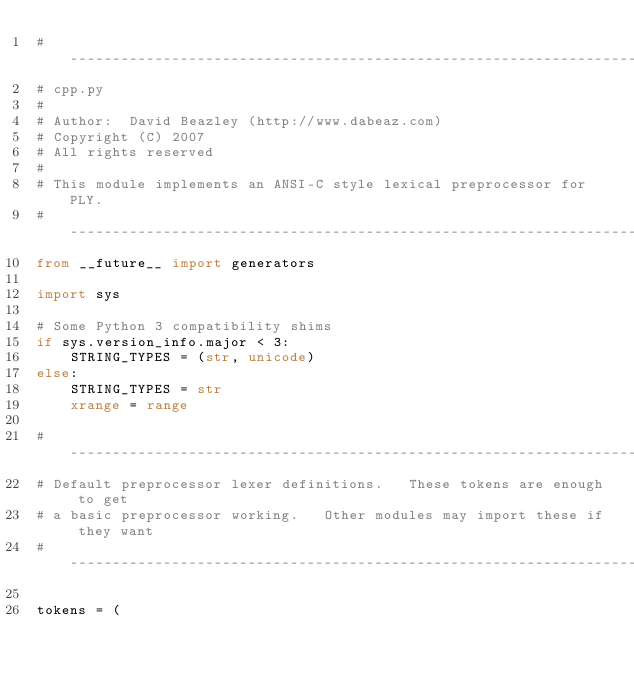<code> <loc_0><loc_0><loc_500><loc_500><_Python_># -----------------------------------------------------------------------------
# cpp.py
#
# Author:  David Beazley (http://www.dabeaz.com)
# Copyright (C) 2007
# All rights reserved
#
# This module implements an ANSI-C style lexical preprocessor for PLY.
# -----------------------------------------------------------------------------
from __future__ import generators

import sys

# Some Python 3 compatibility shims
if sys.version_info.major < 3:
    STRING_TYPES = (str, unicode)
else:
    STRING_TYPES = str
    xrange = range

# -----------------------------------------------------------------------------
# Default preprocessor lexer definitions.   These tokens are enough to get
# a basic preprocessor working.   Other modules may import these if they want
# -----------------------------------------------------------------------------

tokens = (</code> 